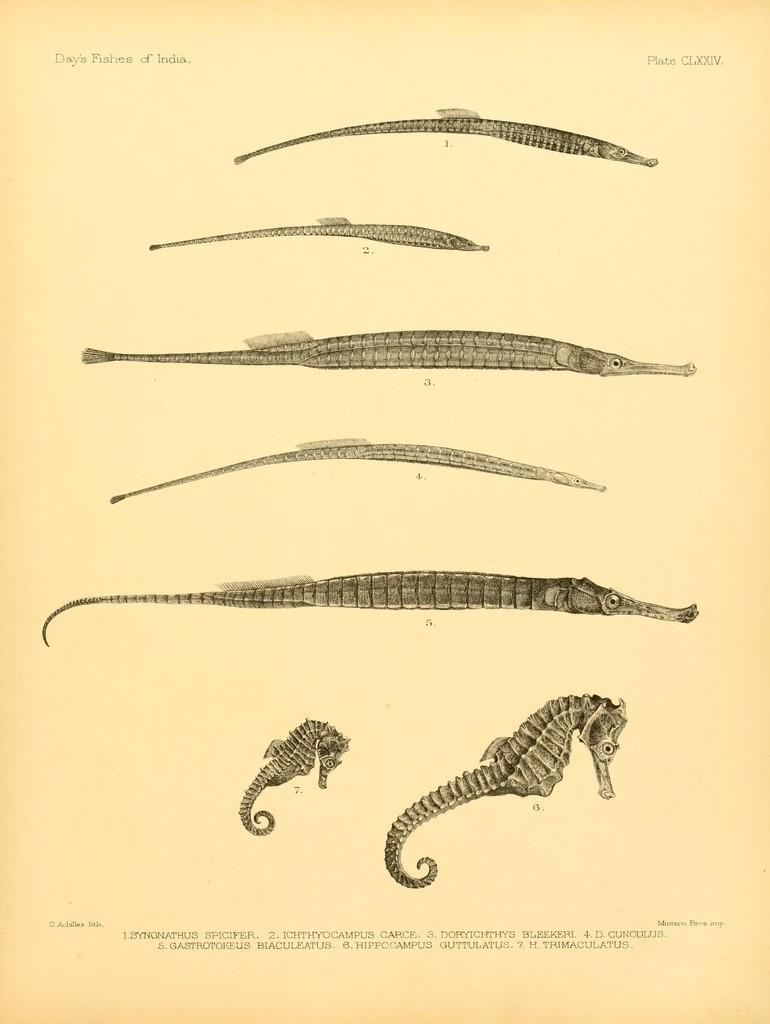What is depicted on the paper in the image? The paper contains stages of a seahorse. What type of information is present on the paper? There is writing on the paper. What type of rifle is being used to whistle in the image? There is no rifle or whistling activity present in the image; it only features a paper with stages of a seahorse and writing. 